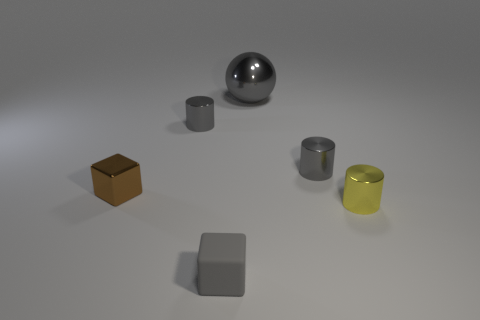Add 3 tiny purple cylinders. How many objects exist? 9 Subtract all balls. How many objects are left? 5 Subtract 0 green cubes. How many objects are left? 6 Subtract all tiny gray rubber objects. Subtract all yellow blocks. How many objects are left? 5 Add 4 brown shiny objects. How many brown shiny objects are left? 5 Add 1 cyan metallic cylinders. How many cyan metallic cylinders exist? 1 